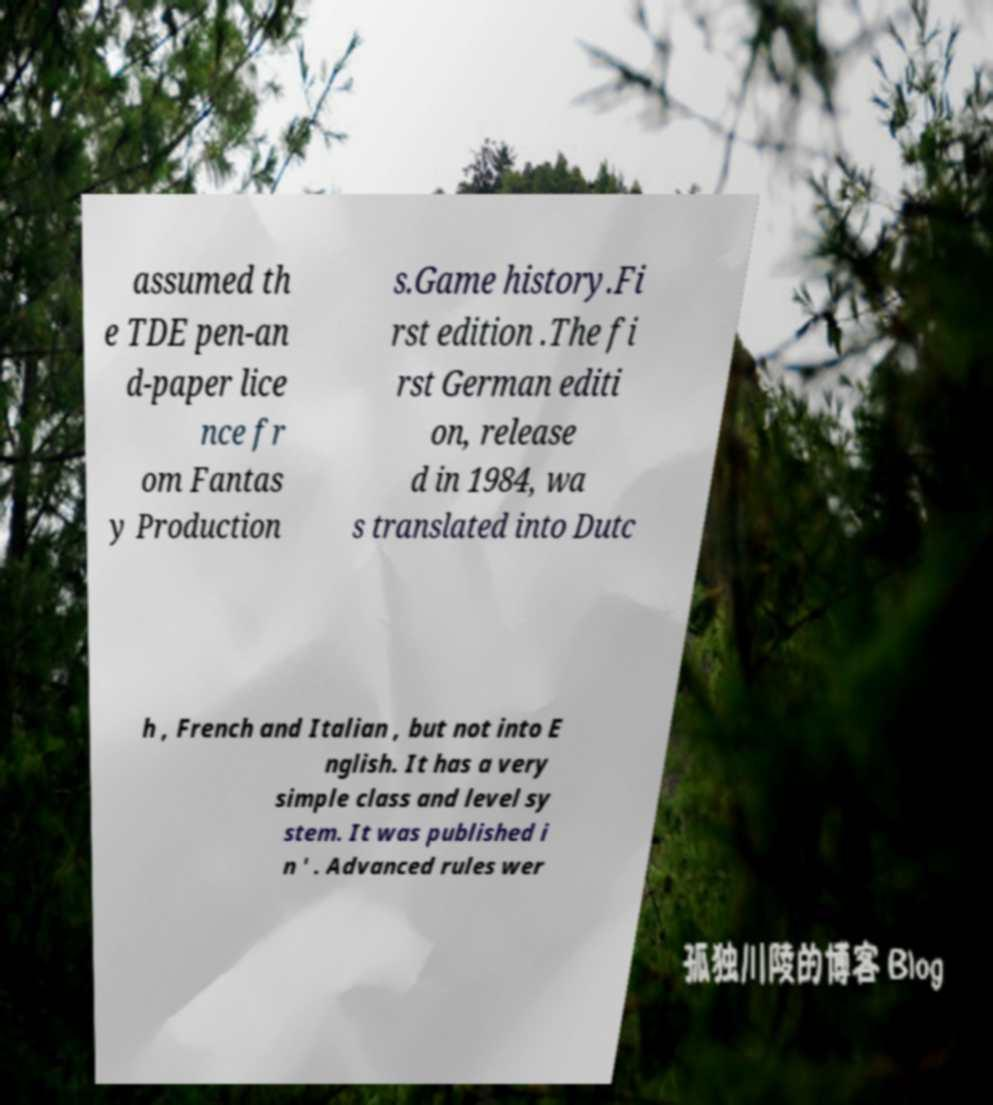There's text embedded in this image that I need extracted. Can you transcribe it verbatim? assumed th e TDE pen-an d-paper lice nce fr om Fantas y Production s.Game history.Fi rst edition .The fi rst German editi on, release d in 1984, wa s translated into Dutc h , French and Italian , but not into E nglish. It has a very simple class and level sy stem. It was published i n ' . Advanced rules wer 